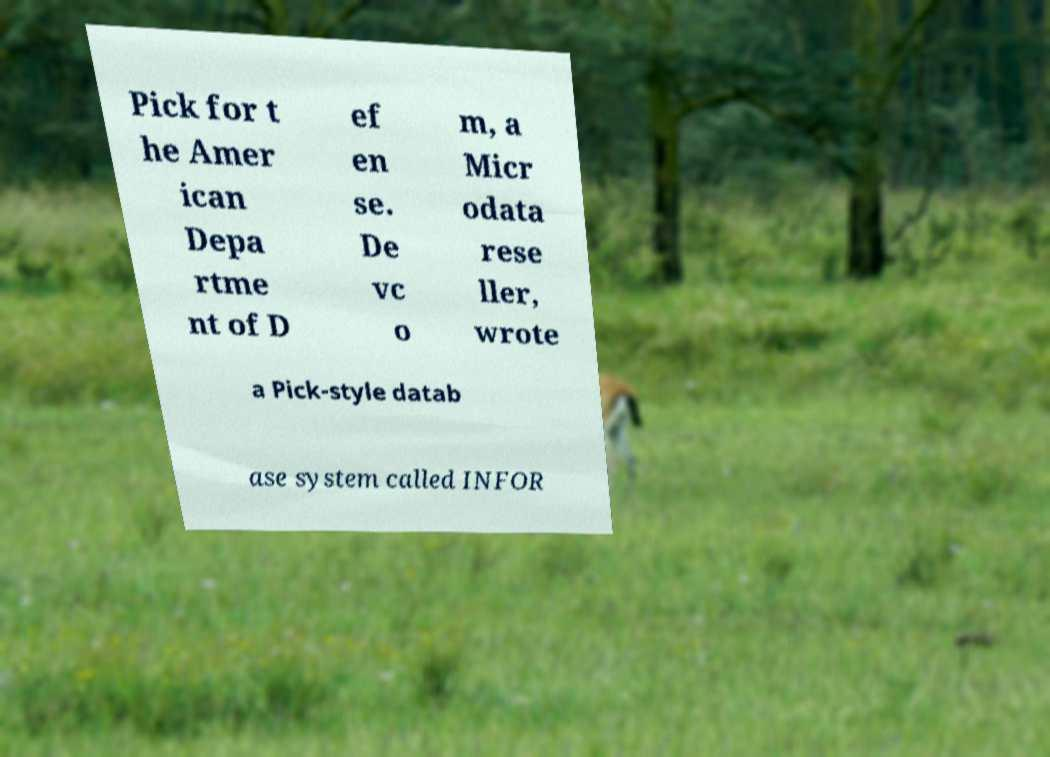Could you extract and type out the text from this image? Pick for t he Amer ican Depa rtme nt of D ef en se. De vc o m, a Micr odata rese ller, wrote a Pick-style datab ase system called INFOR 